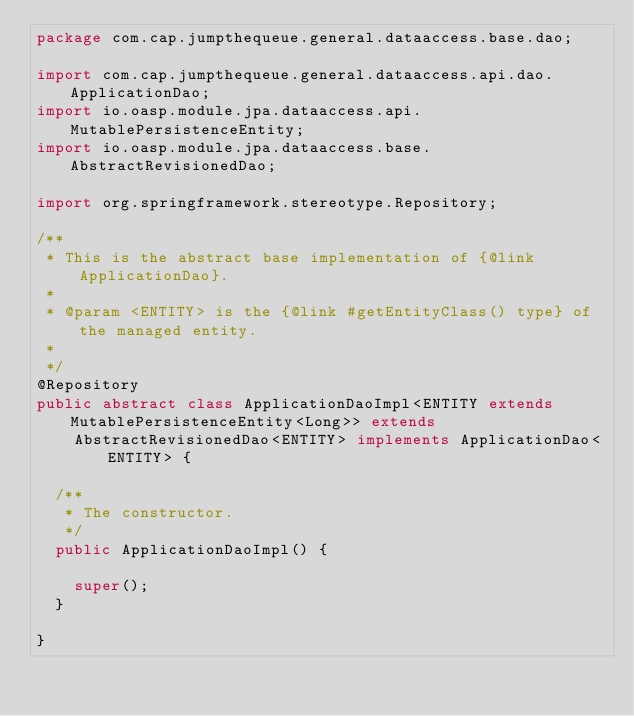<code> <loc_0><loc_0><loc_500><loc_500><_Java_>package com.cap.jumpthequeue.general.dataaccess.base.dao;

import com.cap.jumpthequeue.general.dataaccess.api.dao.ApplicationDao;
import io.oasp.module.jpa.dataaccess.api.MutablePersistenceEntity;
import io.oasp.module.jpa.dataaccess.base.AbstractRevisionedDao;

import org.springframework.stereotype.Repository;

/**
 * This is the abstract base implementation of {@link ApplicationDao}.
 *
 * @param <ENTITY> is the {@link #getEntityClass() type} of the managed entity.
 *
 */
@Repository
public abstract class ApplicationDaoImpl<ENTITY extends MutablePersistenceEntity<Long>> extends
    AbstractRevisionedDao<ENTITY> implements ApplicationDao<ENTITY> {

  /**
   * The constructor.
   */
  public ApplicationDaoImpl() {

    super();
  }

}
</code> 